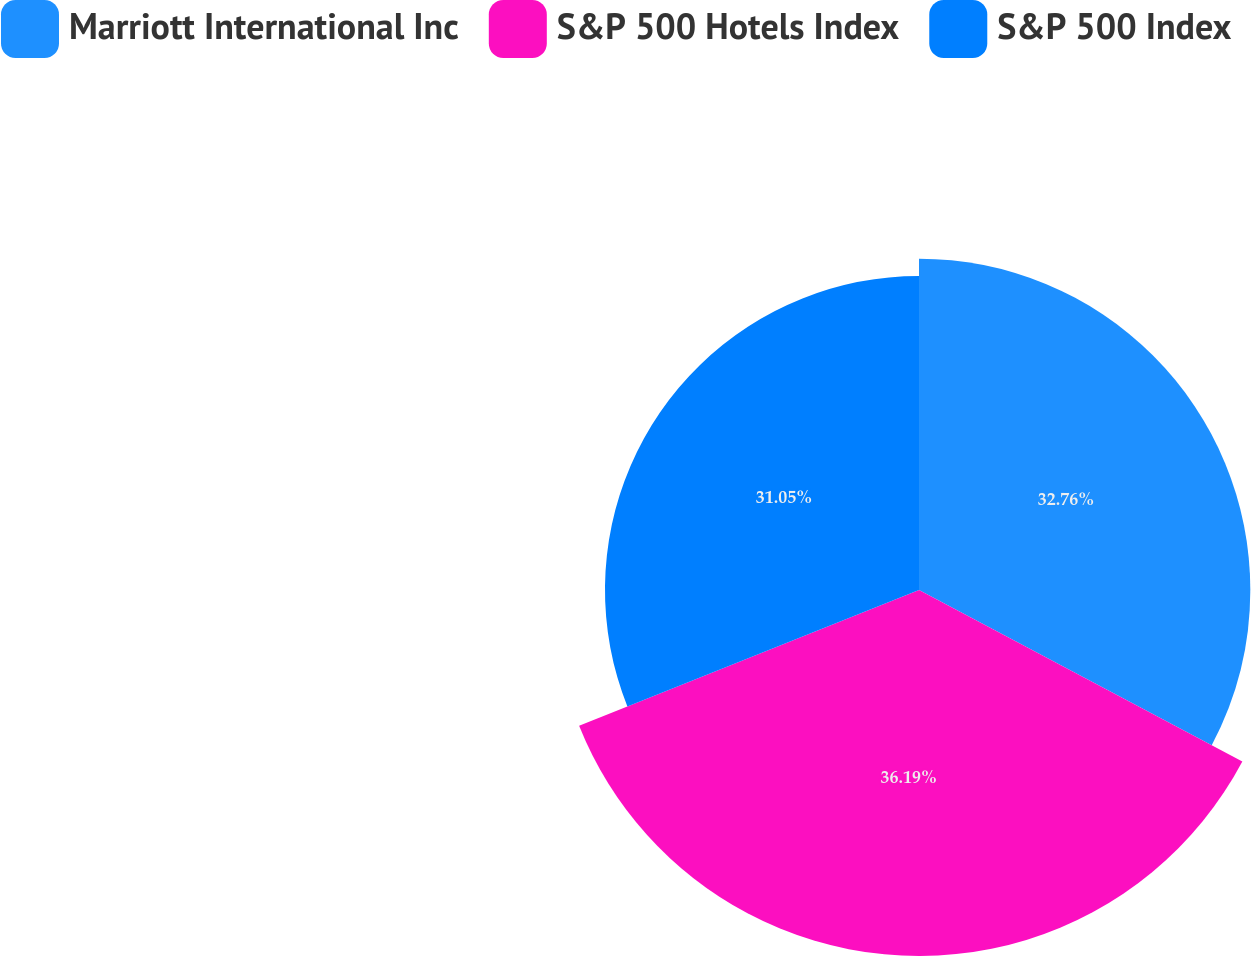<chart> <loc_0><loc_0><loc_500><loc_500><pie_chart><fcel>Marriott International Inc<fcel>S&P 500 Hotels Index<fcel>S&P 500 Index<nl><fcel>32.76%<fcel>36.19%<fcel>31.05%<nl></chart> 